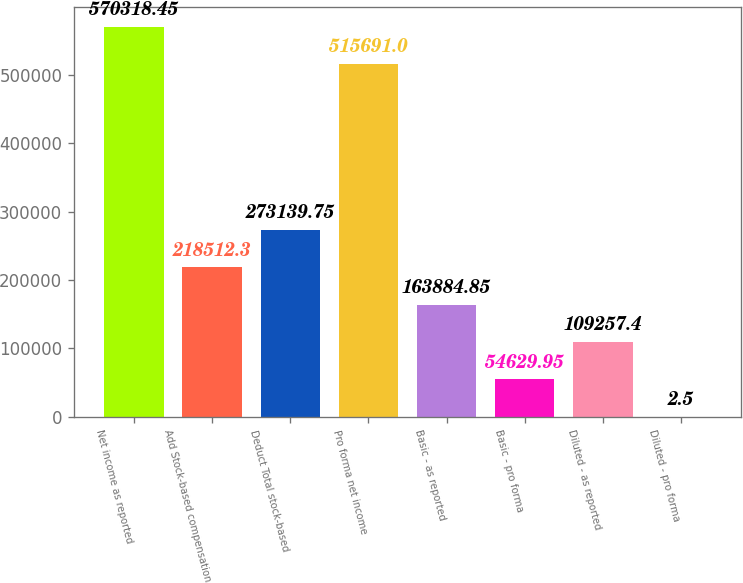Convert chart to OTSL. <chart><loc_0><loc_0><loc_500><loc_500><bar_chart><fcel>Net income as reported<fcel>Add Stock-based compensation<fcel>Deduct Total stock-based<fcel>Pro forma net income<fcel>Basic - as reported<fcel>Basic - pro forma<fcel>Diluted - as reported<fcel>Diluted - pro forma<nl><fcel>570318<fcel>218512<fcel>273140<fcel>515691<fcel>163885<fcel>54629.9<fcel>109257<fcel>2.5<nl></chart> 